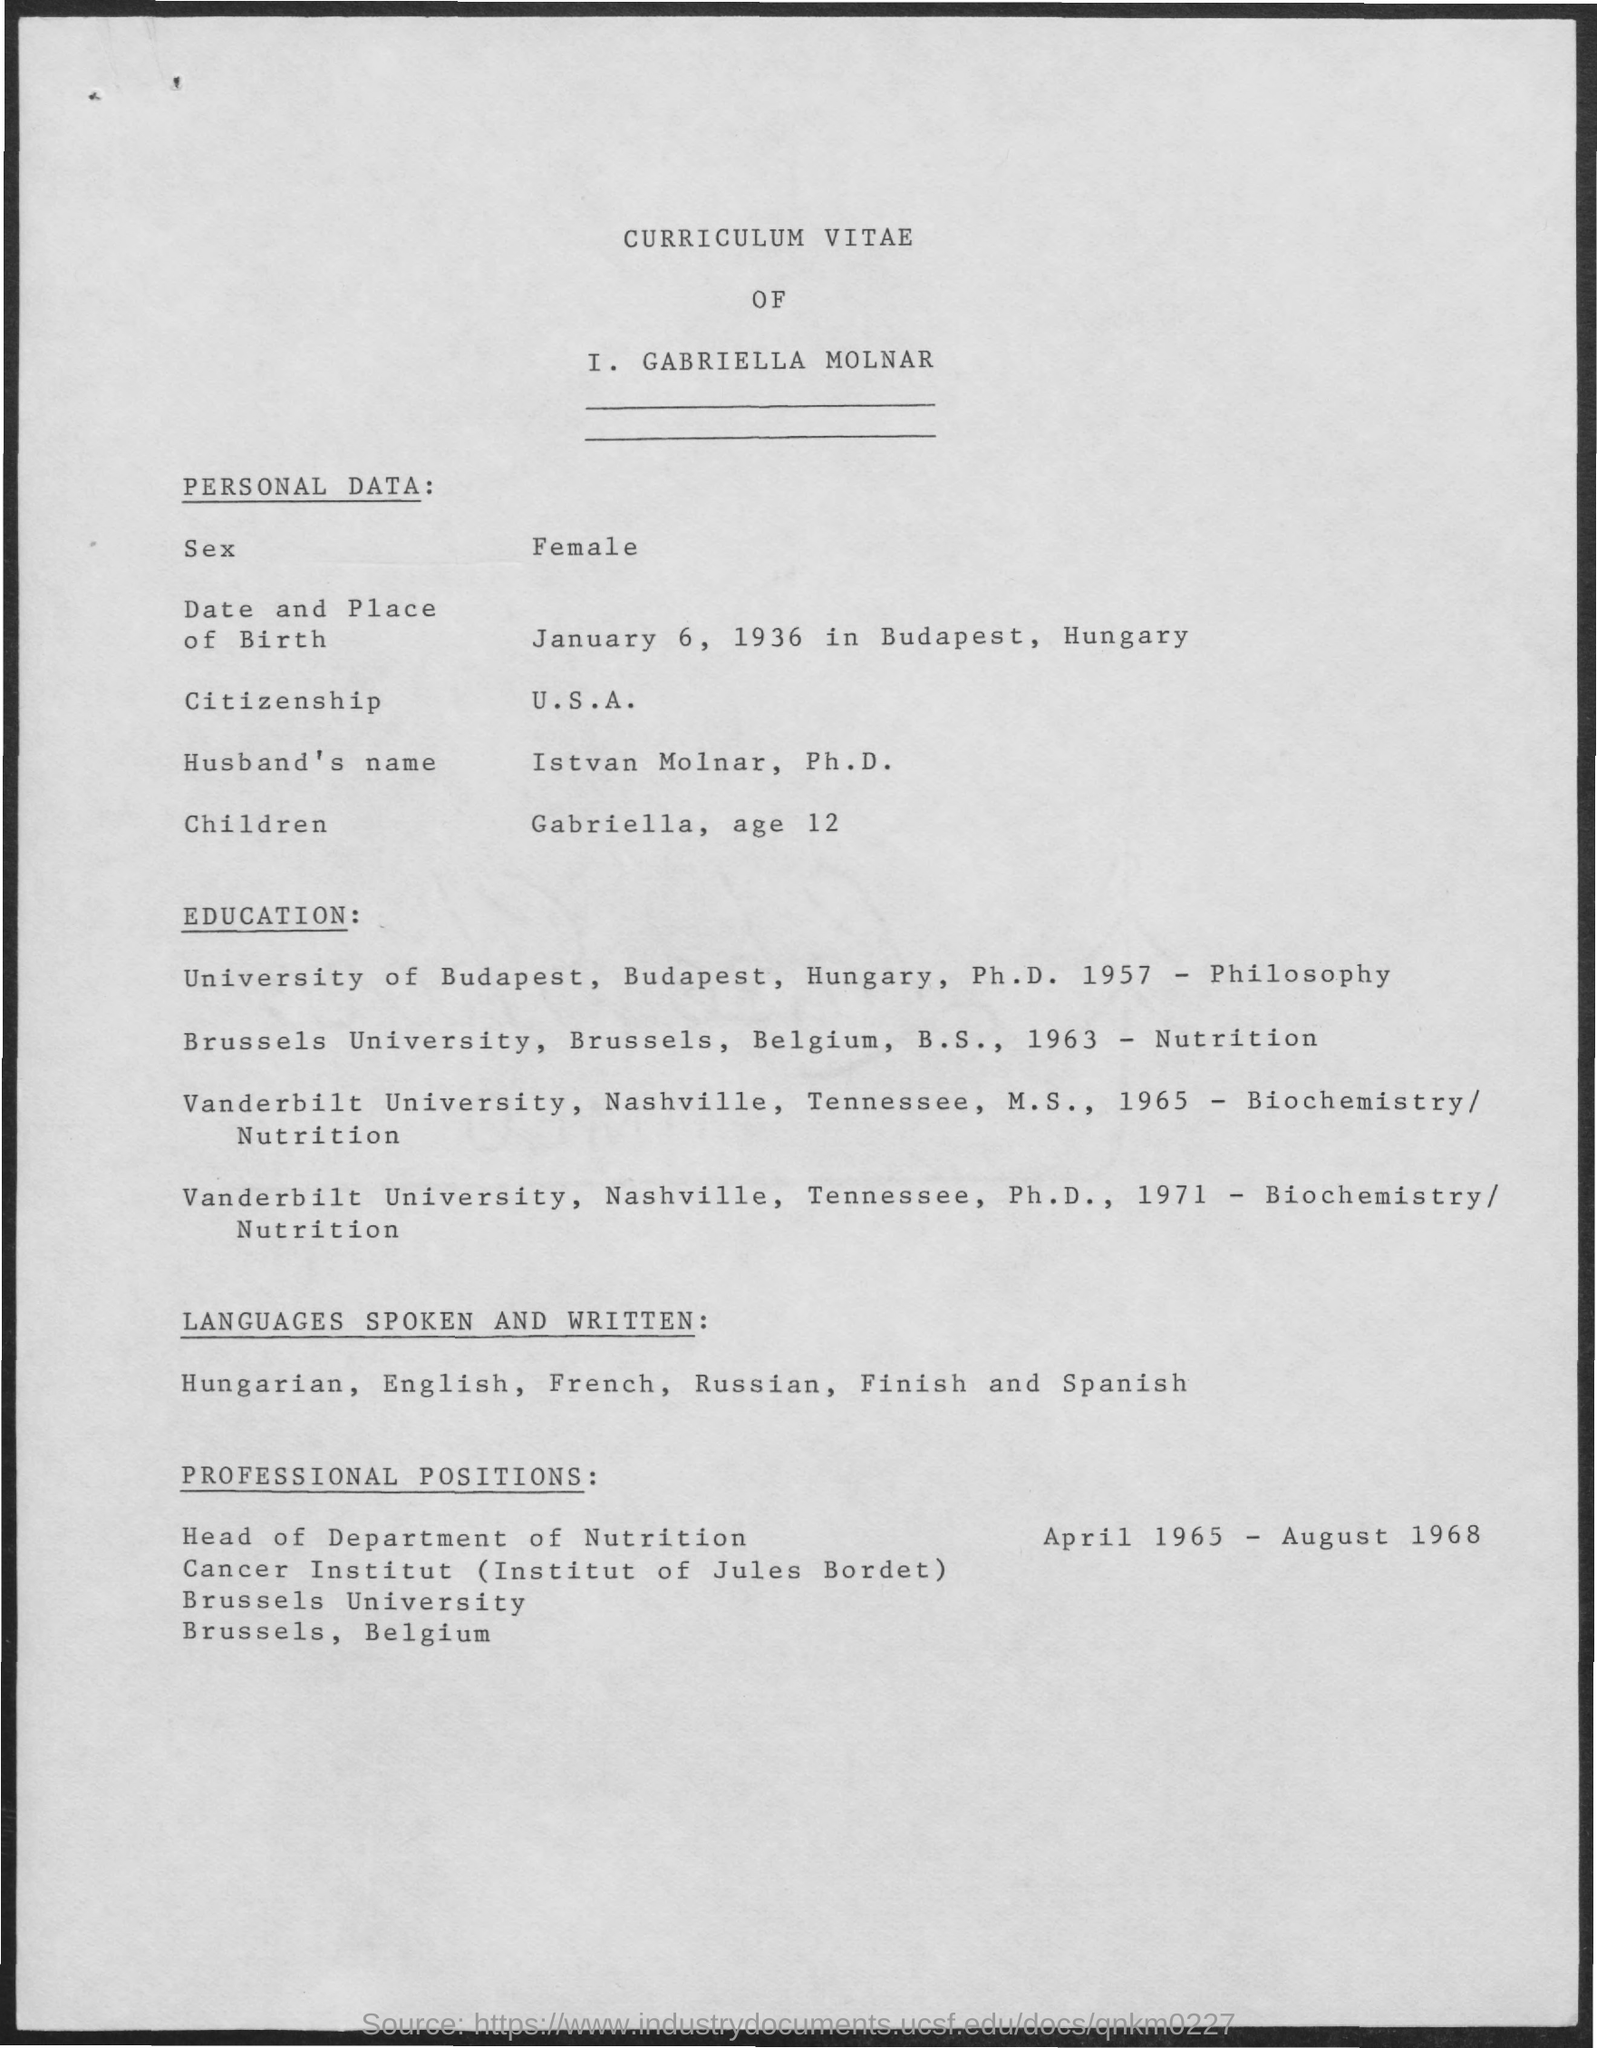What is the date & palce of birth of I. GABRIELLA MOLNAR?
Your answer should be compact. January 6, 1936 in Budapest, Hungary. What is the Citizenship of I. GABRIELLA MOLNAR?
Offer a terse response. U.S.A. 